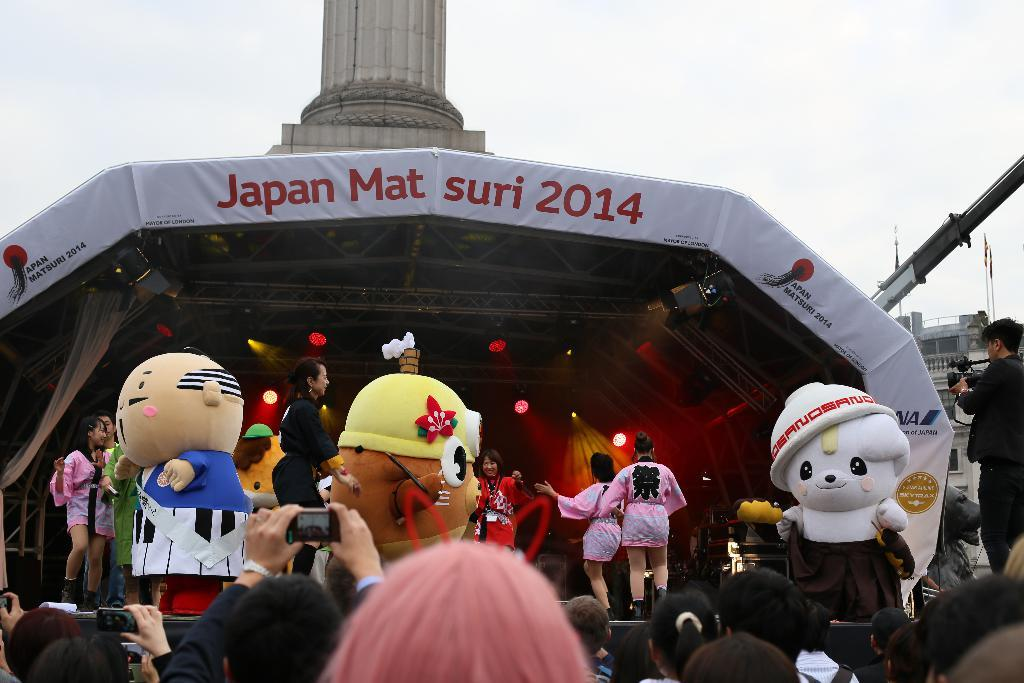How many people are present in the image? There are many people in the image. What are six women doing in the image? Six women are dancing on a dais. What can be observed about three persons in the front? Three persons wearing costumes are in the front. What structure is visible in the background? There is a shed in the background. How many cups of water are being used by the sea in the image? There is no sea present in the image, so it is not possible to determine how many cups of water are being used. 